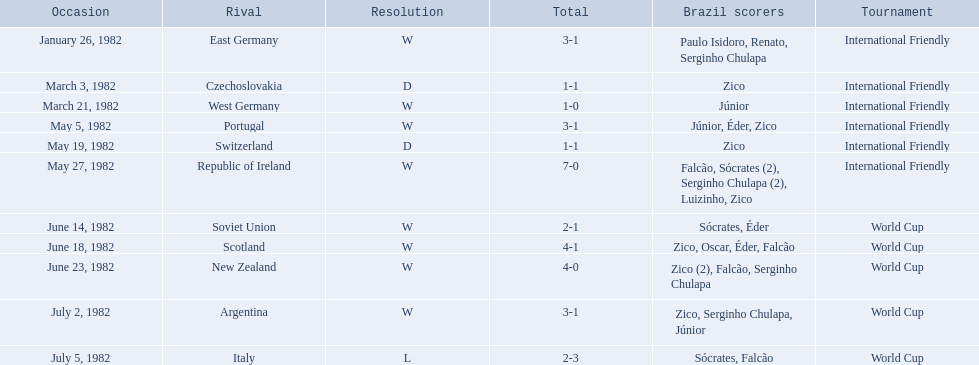Who did brazil play against Soviet Union. Who scored the most goals? Portugal. 